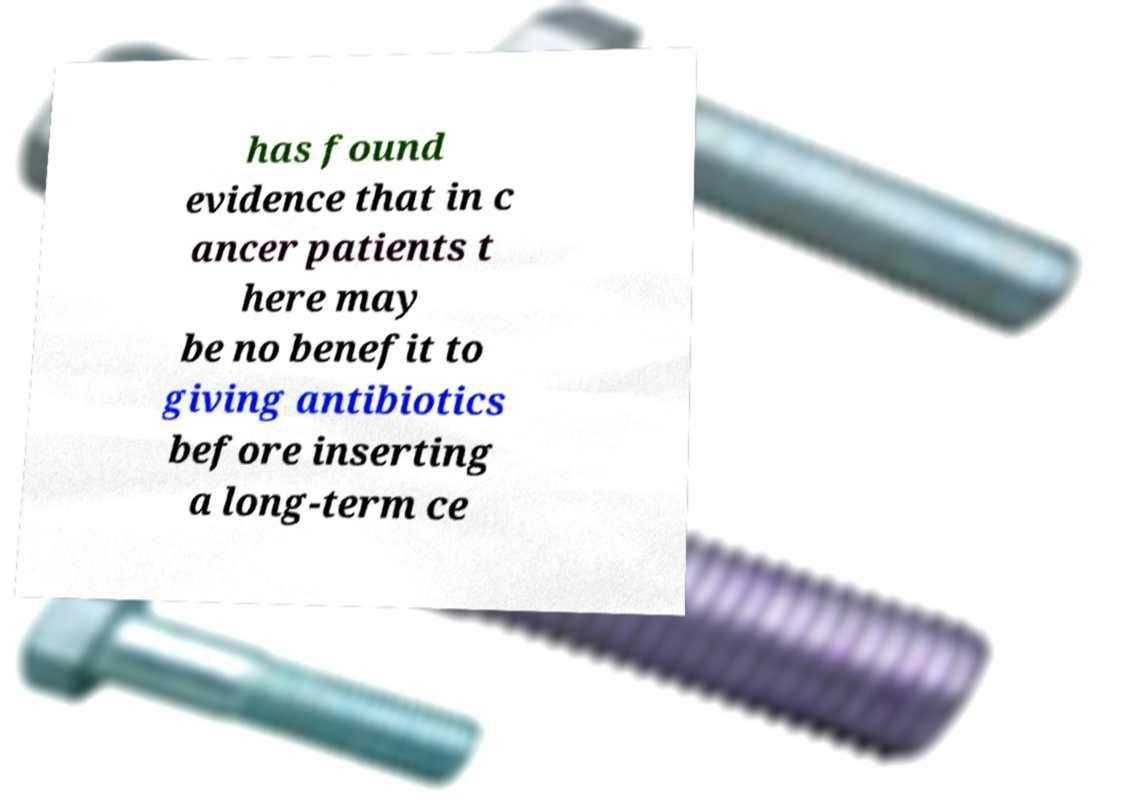Could you assist in decoding the text presented in this image and type it out clearly? has found evidence that in c ancer patients t here may be no benefit to giving antibiotics before inserting a long-term ce 